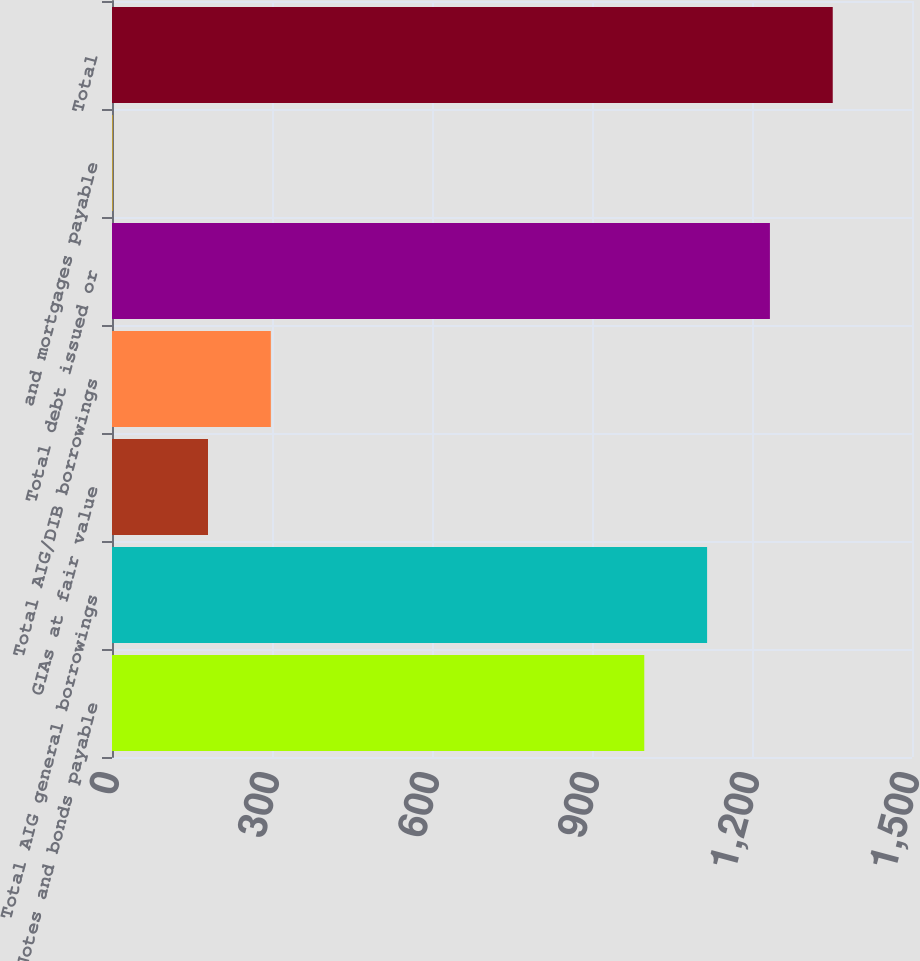<chart> <loc_0><loc_0><loc_500><loc_500><bar_chart><fcel>Notes and bonds payable<fcel>Total AIG general borrowings<fcel>GIAs at fair value<fcel>Total AIG/DIB borrowings<fcel>Total debt issued or<fcel>and mortgages payable<fcel>Total<nl><fcel>998<fcel>1115.8<fcel>180<fcel>297.8<fcel>1233.6<fcel>1<fcel>1351.4<nl></chart> 